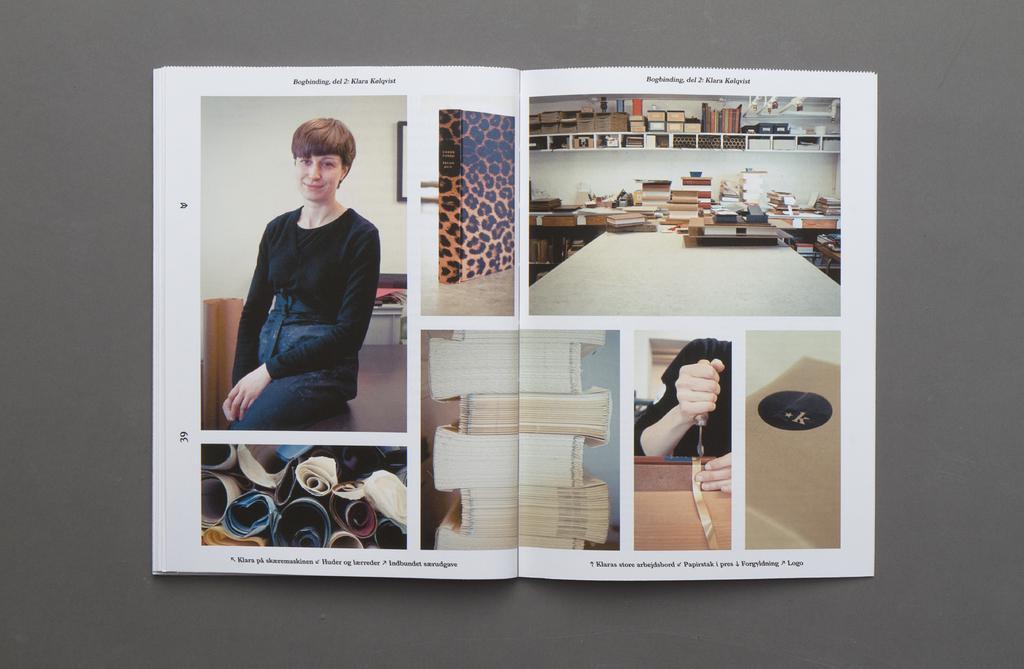Describe this image in one or two sentences. In the middle of the image, there are images of the persons, books and other things and there are texts on the white color pages of a book which is on a surface. And the background is gray in color. 